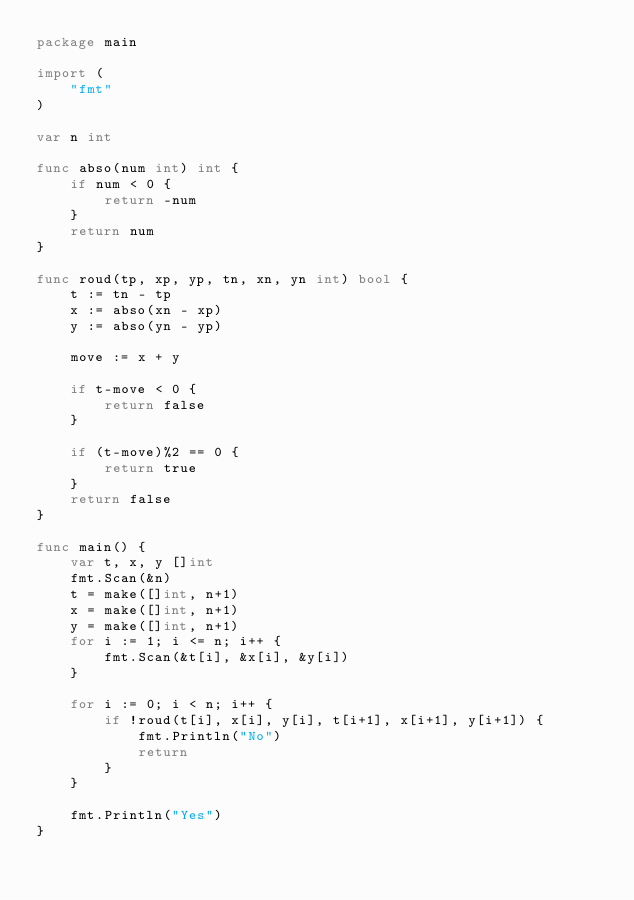<code> <loc_0><loc_0><loc_500><loc_500><_Go_>package main

import (
	"fmt"
)

var n int

func abso(num int) int {
	if num < 0 {
		return -num
	}
	return num
}

func roud(tp, xp, yp, tn, xn, yn int) bool {
	t := tn - tp
	x := abso(xn - xp)
	y := abso(yn - yp)

	move := x + y

	if t-move < 0 {
		return false
	}

	if (t-move)%2 == 0 {
		return true
	}
	return false
}

func main() {
	var t, x, y []int
	fmt.Scan(&n)
	t = make([]int, n+1)
	x = make([]int, n+1)
	y = make([]int, n+1)
	for i := 1; i <= n; i++ {
		fmt.Scan(&t[i], &x[i], &y[i])
	}

	for i := 0; i < n; i++ {
		if !roud(t[i], x[i], y[i], t[i+1], x[i+1], y[i+1]) {
			fmt.Println("No")
			return
		}
	}

	fmt.Println("Yes")
}
</code> 